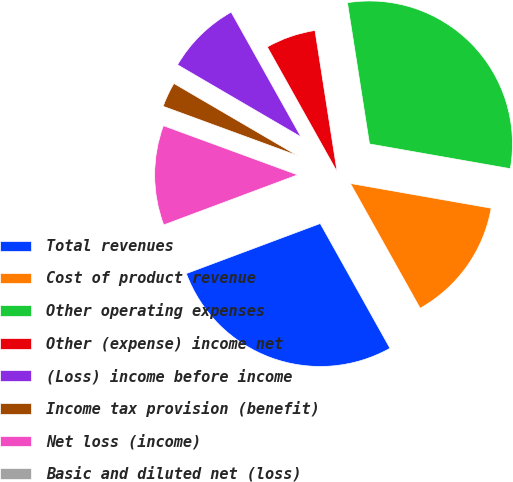Convert chart. <chart><loc_0><loc_0><loc_500><loc_500><pie_chart><fcel>Total revenues<fcel>Cost of product revenue<fcel>Other operating expenses<fcel>Other (expense) income net<fcel>(Loss) income before income<fcel>Income tax provision (benefit)<fcel>Net loss (income)<fcel>Basic and diluted net (loss)<nl><fcel>27.42%<fcel>14.12%<fcel>30.24%<fcel>5.65%<fcel>8.47%<fcel>2.82%<fcel>11.29%<fcel>0.0%<nl></chart> 